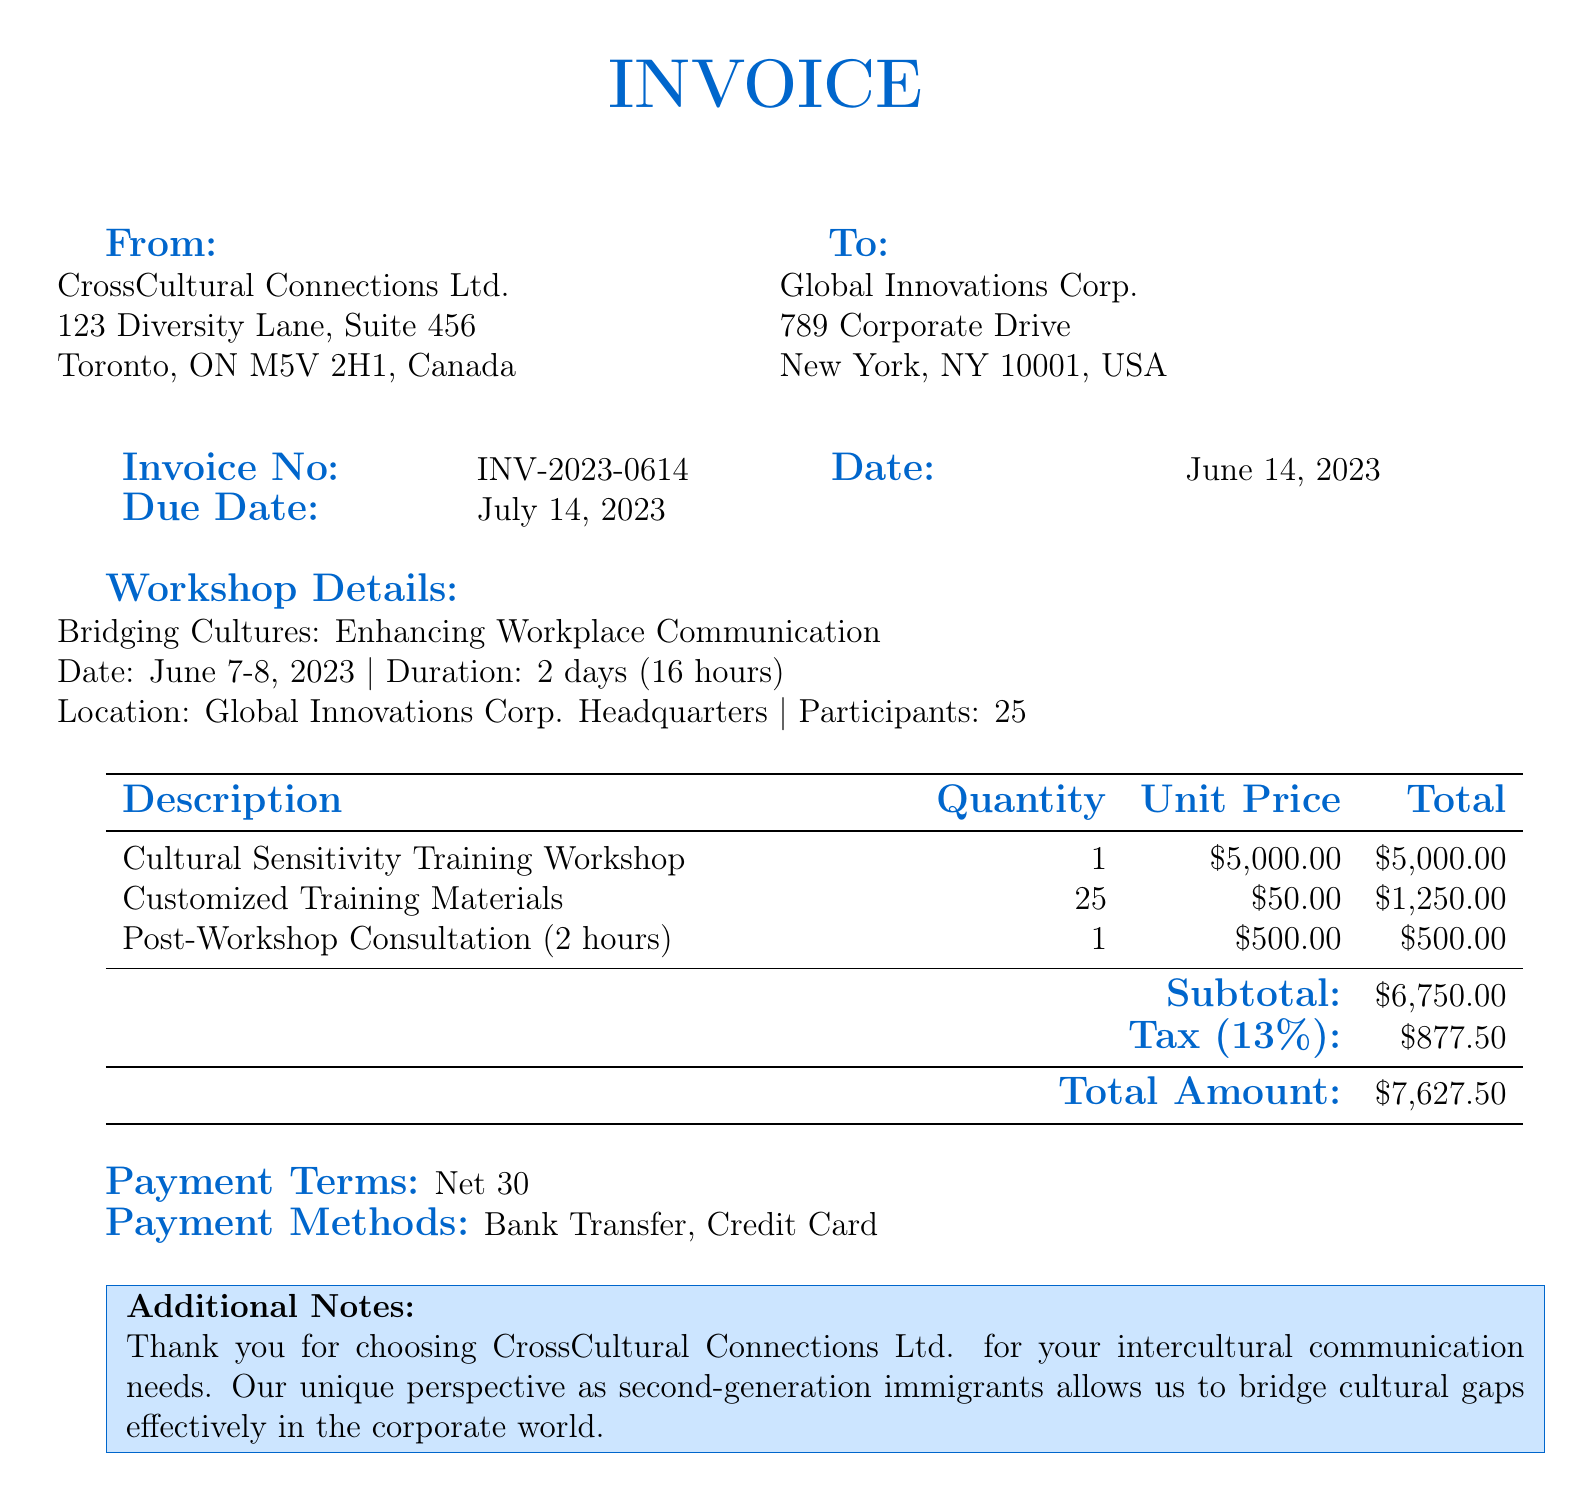What is the invoice number? The invoice number is listed near the top of the document, specifying a unique identifier for this invoice.
Answer: INV-2023-0614 What is the total amount due? The total amount due is calculated at the bottom of the invoice, summarizing all costs, including tax.
Answer: $7,627.50 When was the workshop conducted? The date of the workshop is provided in the workshop details section of the document.
Answer: June 7-8, 2023 How many participants attended the workshop? The participant count is mentioned in the workshop details section.
Answer: 25 What is the subtotal before tax? The subtotal is highlighted before the tax calculation in the invoice.
Answer: $6,750.00 What tax percentage is applied to the invoice? The tax percentage is indicated as part of the financial summary in the document.
Answer: 13% What consultant services were provided after the workshop? The type of service provided post-workshop is listed in the table of charges.
Answer: Post-Workshop Consultation (2 hours) What payment terms are specified in the invoice? Payment terms are stated clearly to provide the client with information on when payment is due.
Answer: Net 30 What company conducted the workshop? The company that provided the workshop services is featured at the top of the invoice.
Answer: CrossCultural Connections Ltd 